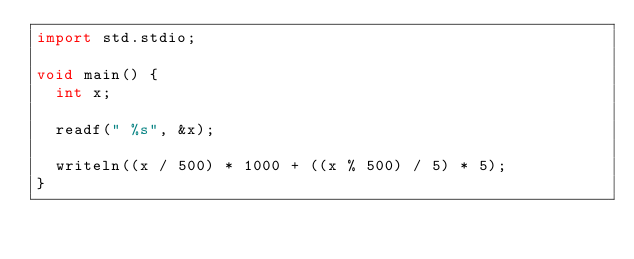Convert code to text. <code><loc_0><loc_0><loc_500><loc_500><_D_>import std.stdio;

void main() {
	int x;

	readf(" %s", &x);

	writeln((x / 500) * 1000 + ((x % 500) / 5) * 5);
}
</code> 